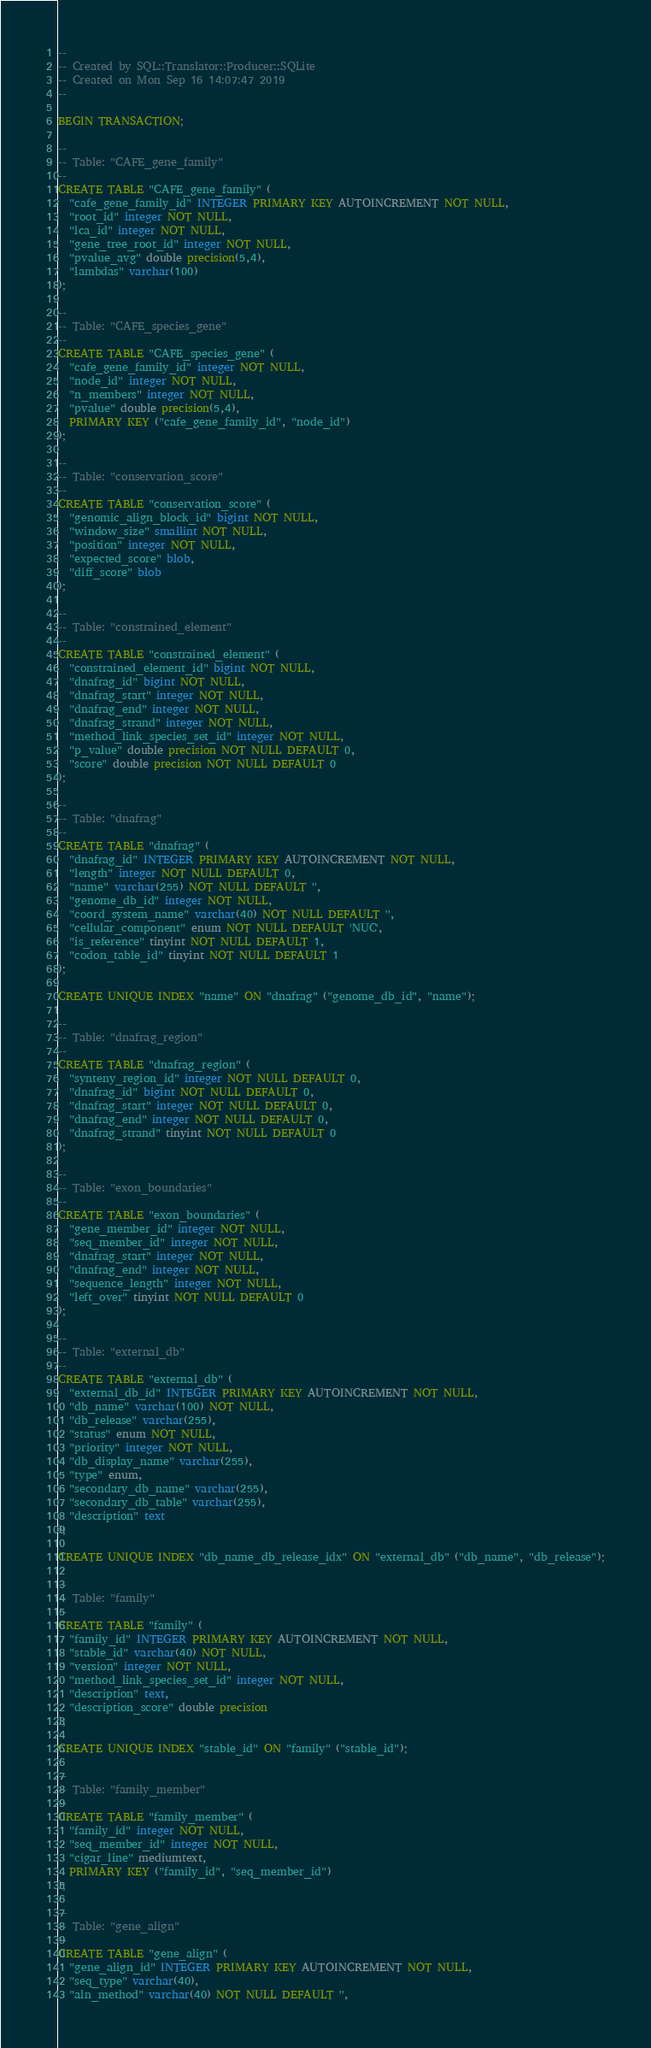<code> <loc_0><loc_0><loc_500><loc_500><_SQL_>-- 
-- Created by SQL::Translator::Producer::SQLite
-- Created on Mon Sep 16 14:07:47 2019
-- 

BEGIN TRANSACTION;

--
-- Table: "CAFE_gene_family"
--
CREATE TABLE "CAFE_gene_family" (
  "cafe_gene_family_id" INTEGER PRIMARY KEY AUTOINCREMENT NOT NULL,
  "root_id" integer NOT NULL,
  "lca_id" integer NOT NULL,
  "gene_tree_root_id" integer NOT NULL,
  "pvalue_avg" double precision(5,4),
  "lambdas" varchar(100)
);

--
-- Table: "CAFE_species_gene"
--
CREATE TABLE "CAFE_species_gene" (
  "cafe_gene_family_id" integer NOT NULL,
  "node_id" integer NOT NULL,
  "n_members" integer NOT NULL,
  "pvalue" double precision(5,4),
  PRIMARY KEY ("cafe_gene_family_id", "node_id")
);

--
-- Table: "conservation_score"
--
CREATE TABLE "conservation_score" (
  "genomic_align_block_id" bigint NOT NULL,
  "window_size" smallint NOT NULL,
  "position" integer NOT NULL,
  "expected_score" blob,
  "diff_score" blob
);

--
-- Table: "constrained_element"
--
CREATE TABLE "constrained_element" (
  "constrained_element_id" bigint NOT NULL,
  "dnafrag_id" bigint NOT NULL,
  "dnafrag_start" integer NOT NULL,
  "dnafrag_end" integer NOT NULL,
  "dnafrag_strand" integer NOT NULL,
  "method_link_species_set_id" integer NOT NULL,
  "p_value" double precision NOT NULL DEFAULT 0,
  "score" double precision NOT NULL DEFAULT 0
);

--
-- Table: "dnafrag"
--
CREATE TABLE "dnafrag" (
  "dnafrag_id" INTEGER PRIMARY KEY AUTOINCREMENT NOT NULL,
  "length" integer NOT NULL DEFAULT 0,
  "name" varchar(255) NOT NULL DEFAULT '',
  "genome_db_id" integer NOT NULL,
  "coord_system_name" varchar(40) NOT NULL DEFAULT '',
  "cellular_component" enum NOT NULL DEFAULT 'NUC',
  "is_reference" tinyint NOT NULL DEFAULT 1,
  "codon_table_id" tinyint NOT NULL DEFAULT 1
);

CREATE UNIQUE INDEX "name" ON "dnafrag" ("genome_db_id", "name");

--
-- Table: "dnafrag_region"
--
CREATE TABLE "dnafrag_region" (
  "synteny_region_id" integer NOT NULL DEFAULT 0,
  "dnafrag_id" bigint NOT NULL DEFAULT 0,
  "dnafrag_start" integer NOT NULL DEFAULT 0,
  "dnafrag_end" integer NOT NULL DEFAULT 0,
  "dnafrag_strand" tinyint NOT NULL DEFAULT 0
);

--
-- Table: "exon_boundaries"
--
CREATE TABLE "exon_boundaries" (
  "gene_member_id" integer NOT NULL,
  "seq_member_id" integer NOT NULL,
  "dnafrag_start" integer NOT NULL,
  "dnafrag_end" integer NOT NULL,
  "sequence_length" integer NOT NULL,
  "left_over" tinyint NOT NULL DEFAULT 0
);

--
-- Table: "external_db"
--
CREATE TABLE "external_db" (
  "external_db_id" INTEGER PRIMARY KEY AUTOINCREMENT NOT NULL,
  "db_name" varchar(100) NOT NULL,
  "db_release" varchar(255),
  "status" enum NOT NULL,
  "priority" integer NOT NULL,
  "db_display_name" varchar(255),
  "type" enum,
  "secondary_db_name" varchar(255),
  "secondary_db_table" varchar(255),
  "description" text
);

CREATE UNIQUE INDEX "db_name_db_release_idx" ON "external_db" ("db_name", "db_release");

--
-- Table: "family"
--
CREATE TABLE "family" (
  "family_id" INTEGER PRIMARY KEY AUTOINCREMENT NOT NULL,
  "stable_id" varchar(40) NOT NULL,
  "version" integer NOT NULL,
  "method_link_species_set_id" integer NOT NULL,
  "description" text,
  "description_score" double precision
);

CREATE UNIQUE INDEX "stable_id" ON "family" ("stable_id");

--
-- Table: "family_member"
--
CREATE TABLE "family_member" (
  "family_id" integer NOT NULL,
  "seq_member_id" integer NOT NULL,
  "cigar_line" mediumtext,
  PRIMARY KEY ("family_id", "seq_member_id")
);

--
-- Table: "gene_align"
--
CREATE TABLE "gene_align" (
  "gene_align_id" INTEGER PRIMARY KEY AUTOINCREMENT NOT NULL,
  "seq_type" varchar(40),
  "aln_method" varchar(40) NOT NULL DEFAULT '',</code> 